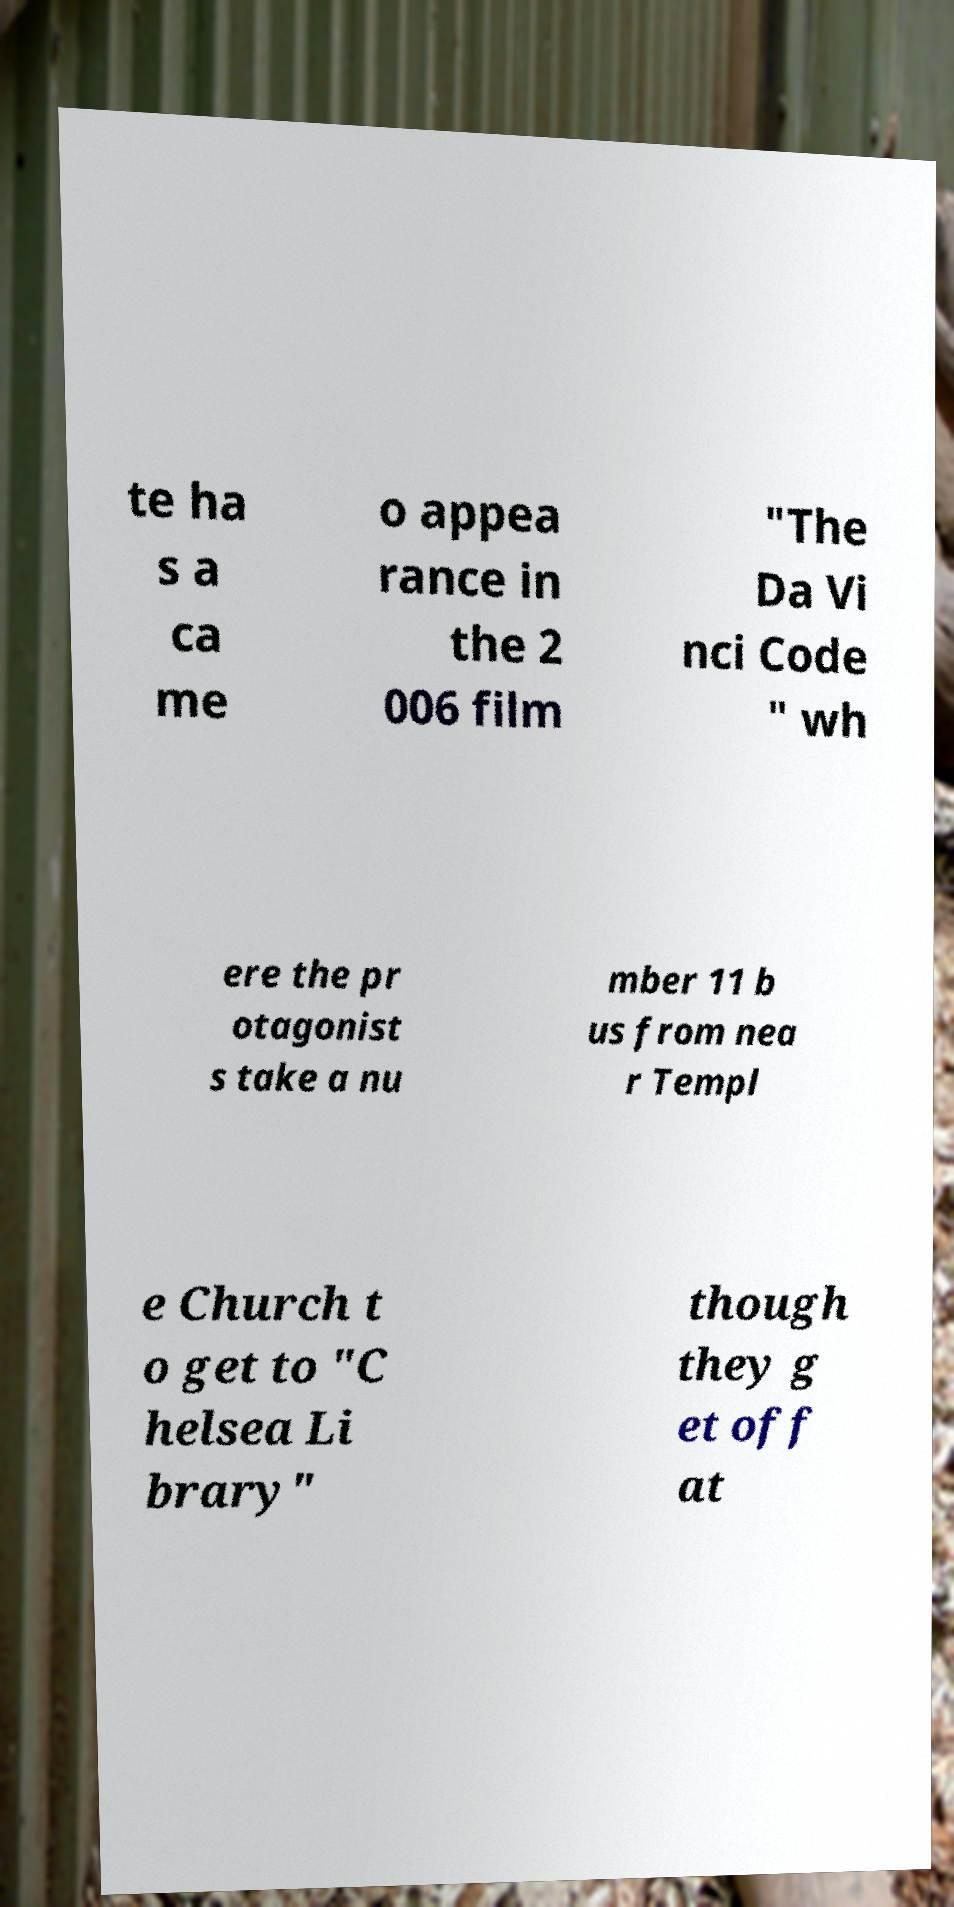Please identify and transcribe the text found in this image. te ha s a ca me o appea rance in the 2 006 film "The Da Vi nci Code " wh ere the pr otagonist s take a nu mber 11 b us from nea r Templ e Church t o get to "C helsea Li brary" though they g et off at 